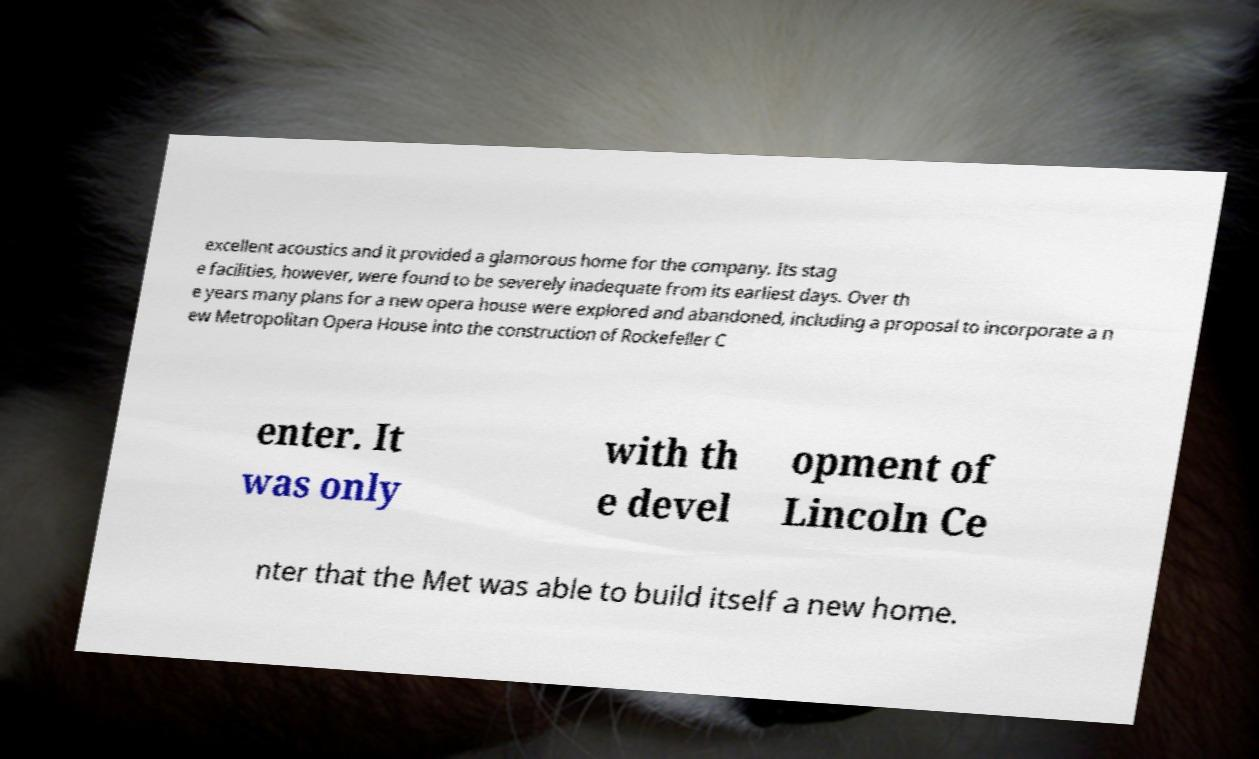Can you read and provide the text displayed in the image?This photo seems to have some interesting text. Can you extract and type it out for me? excellent acoustics and it provided a glamorous home for the company. Its stag e facilities, however, were found to be severely inadequate from its earliest days. Over th e years many plans for a new opera house were explored and abandoned, including a proposal to incorporate a n ew Metropolitan Opera House into the construction of Rockefeller C enter. It was only with th e devel opment of Lincoln Ce nter that the Met was able to build itself a new home. 